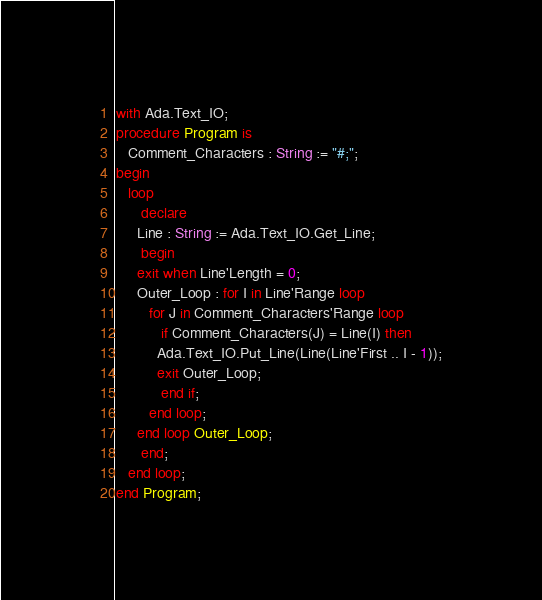Convert code to text. <code><loc_0><loc_0><loc_500><loc_500><_Ada_>with Ada.Text_IO;
procedure Program is
   Comment_Characters : String := "#;";
begin
   loop
      declare
	 Line : String := Ada.Text_IO.Get_Line;
      begin
	 exit when Line'Length = 0;
	 Outer_Loop : for I in Line'Range loop
	    for J in Comment_Characters'Range loop
	       if Comment_Characters(J) = Line(I) then
		  Ada.Text_IO.Put_Line(Line(Line'First .. I - 1));
		  exit Outer_Loop;
	       end if;
	    end loop;
	 end loop Outer_Loop;
      end;
   end loop;
end Program;
</code> 